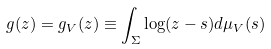<formula> <loc_0><loc_0><loc_500><loc_500>g ( z ) = g _ { V } ( z ) \equiv \int _ { \Sigma } \log ( z - s ) d \mu _ { V } ( s )</formula> 